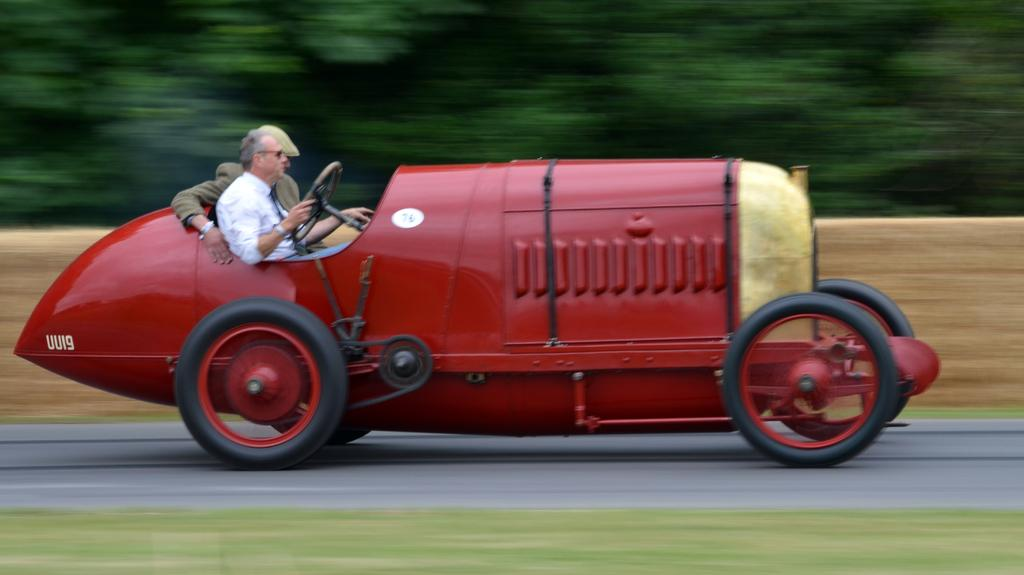What can be observed about the background of the image? The background of the image is blurry. How many people are in the image? There are two men in the image. Where are the men located in the image? The men are sitting inside a vehicle. What is the status of the vehicle in the image? The vehicle is in motion. What type of natural environment is visible in the image? There is grass visible in the image. What type of man-made structure is present in the image? There is a road in the image. Can you tell me how many ladybugs are crawling on the road in the image? There are no ladybugs visible in the image; only a road and grass are present. What type of girl can be seen playing with the men in the vehicle? There is no girl present in the image; only two men are visible. 